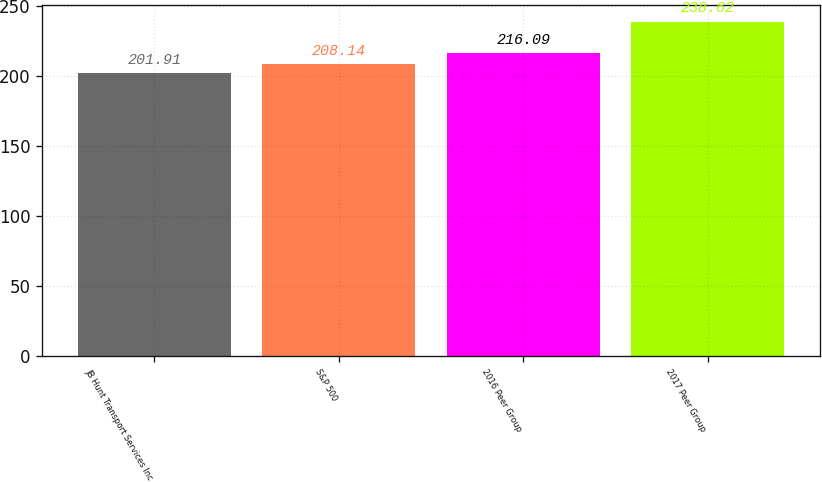Convert chart to OTSL. <chart><loc_0><loc_0><loc_500><loc_500><bar_chart><fcel>JB Hunt Transport Services Inc<fcel>S&P 500<fcel>2016 Peer Group<fcel>2017 Peer Group<nl><fcel>201.91<fcel>208.14<fcel>216.09<fcel>238.62<nl></chart> 